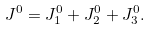Convert formula to latex. <formula><loc_0><loc_0><loc_500><loc_500>J ^ { 0 } = J _ { 1 } ^ { 0 } + J _ { 2 } ^ { 0 } + J _ { 3 } ^ { 0 } .</formula> 